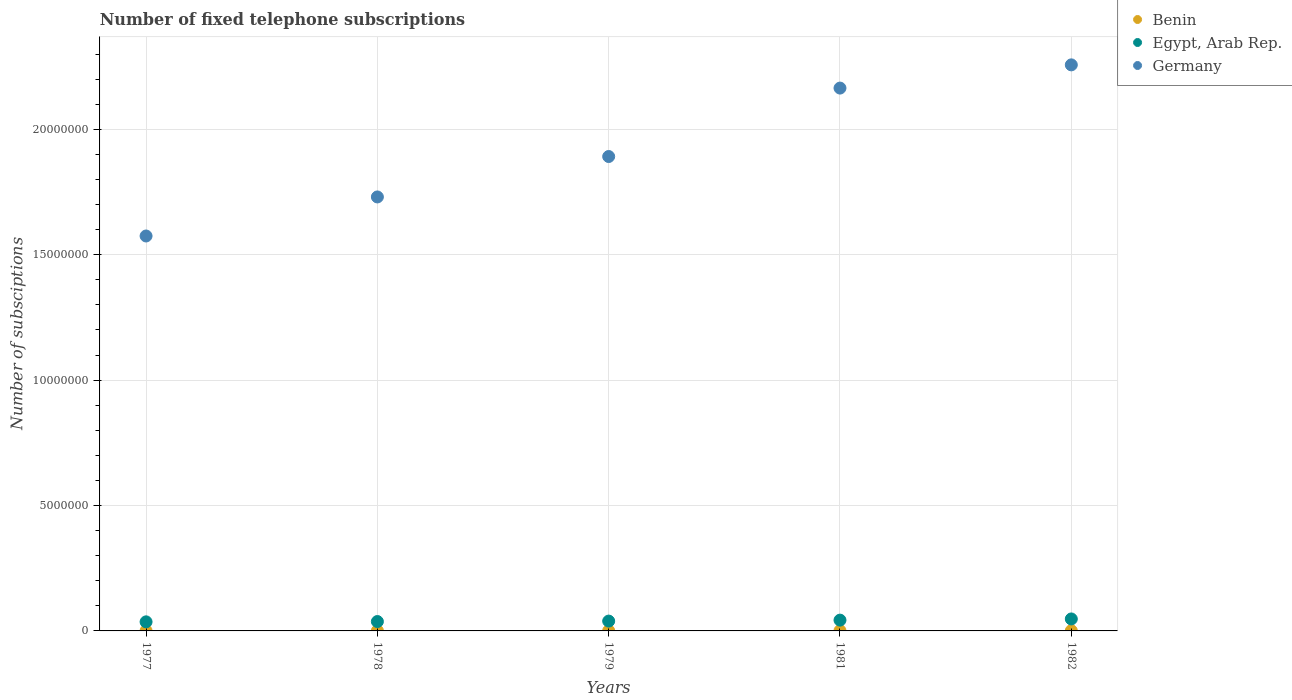Is the number of dotlines equal to the number of legend labels?
Make the answer very short. Yes. What is the number of fixed telephone subscriptions in Germany in 1978?
Provide a short and direct response. 1.73e+07. Across all years, what is the maximum number of fixed telephone subscriptions in Egypt, Arab Rep.?
Provide a short and direct response. 4.77e+05. Across all years, what is the minimum number of fixed telephone subscriptions in Benin?
Offer a very short reply. 6371. In which year was the number of fixed telephone subscriptions in Egypt, Arab Rep. minimum?
Ensure brevity in your answer.  1977. What is the total number of fixed telephone subscriptions in Germany in the graph?
Offer a terse response. 9.62e+07. What is the difference between the number of fixed telephone subscriptions in Egypt, Arab Rep. in 1977 and that in 1981?
Provide a succinct answer. -6.80e+04. What is the difference between the number of fixed telephone subscriptions in Egypt, Arab Rep. in 1978 and the number of fixed telephone subscriptions in Germany in 1977?
Keep it short and to the point. -1.54e+07. What is the average number of fixed telephone subscriptions in Benin per year?
Give a very brief answer. 8036.8. In the year 1982, what is the difference between the number of fixed telephone subscriptions in Germany and number of fixed telephone subscriptions in Benin?
Provide a succinct answer. 2.26e+07. In how many years, is the number of fixed telephone subscriptions in Germany greater than 3000000?
Make the answer very short. 5. What is the ratio of the number of fixed telephone subscriptions in Benin in 1977 to that in 1978?
Offer a terse response. 0.91. Is the number of fixed telephone subscriptions in Benin in 1977 less than that in 1981?
Your answer should be very brief. Yes. What is the difference between the highest and the second highest number of fixed telephone subscriptions in Egypt, Arab Rep.?
Your response must be concise. 4.74e+04. What is the difference between the highest and the lowest number of fixed telephone subscriptions in Benin?
Provide a short and direct response. 3309. Is the sum of the number of fixed telephone subscriptions in Benin in 1978 and 1981 greater than the maximum number of fixed telephone subscriptions in Germany across all years?
Provide a succinct answer. No. Is it the case that in every year, the sum of the number of fixed telephone subscriptions in Germany and number of fixed telephone subscriptions in Egypt, Arab Rep.  is greater than the number of fixed telephone subscriptions in Benin?
Keep it short and to the point. Yes. Does the number of fixed telephone subscriptions in Germany monotonically increase over the years?
Your response must be concise. Yes. Is the number of fixed telephone subscriptions in Benin strictly greater than the number of fixed telephone subscriptions in Germany over the years?
Ensure brevity in your answer.  No. Is the number of fixed telephone subscriptions in Benin strictly less than the number of fixed telephone subscriptions in Germany over the years?
Make the answer very short. Yes. What is the difference between two consecutive major ticks on the Y-axis?
Your answer should be compact. 5.00e+06. Does the graph contain any zero values?
Provide a short and direct response. No. Does the graph contain grids?
Offer a terse response. Yes. What is the title of the graph?
Make the answer very short. Number of fixed telephone subscriptions. What is the label or title of the X-axis?
Give a very brief answer. Years. What is the label or title of the Y-axis?
Ensure brevity in your answer.  Number of subsciptions. What is the Number of subsciptions of Benin in 1977?
Your response must be concise. 6371. What is the Number of subsciptions of Egypt, Arab Rep. in 1977?
Make the answer very short. 3.62e+05. What is the Number of subsciptions in Germany in 1977?
Your answer should be very brief. 1.57e+07. What is the Number of subsciptions of Benin in 1978?
Give a very brief answer. 7032. What is the Number of subsciptions of Egypt, Arab Rep. in 1978?
Ensure brevity in your answer.  3.74e+05. What is the Number of subsciptions in Germany in 1978?
Your response must be concise. 1.73e+07. What is the Number of subsciptions of Benin in 1979?
Ensure brevity in your answer.  7692. What is the Number of subsciptions of Egypt, Arab Rep. in 1979?
Ensure brevity in your answer.  3.92e+05. What is the Number of subsciptions in Germany in 1979?
Your answer should be very brief. 1.89e+07. What is the Number of subsciptions in Benin in 1981?
Make the answer very short. 9409. What is the Number of subsciptions in Egypt, Arab Rep. in 1981?
Provide a short and direct response. 4.30e+05. What is the Number of subsciptions in Germany in 1981?
Provide a succinct answer. 2.16e+07. What is the Number of subsciptions in Benin in 1982?
Provide a succinct answer. 9680. What is the Number of subsciptions of Egypt, Arab Rep. in 1982?
Offer a very short reply. 4.77e+05. What is the Number of subsciptions of Germany in 1982?
Your answer should be compact. 2.26e+07. Across all years, what is the maximum Number of subsciptions in Benin?
Keep it short and to the point. 9680. Across all years, what is the maximum Number of subsciptions in Egypt, Arab Rep.?
Offer a very short reply. 4.77e+05. Across all years, what is the maximum Number of subsciptions of Germany?
Ensure brevity in your answer.  2.26e+07. Across all years, what is the minimum Number of subsciptions in Benin?
Keep it short and to the point. 6371. Across all years, what is the minimum Number of subsciptions in Egypt, Arab Rep.?
Keep it short and to the point. 3.62e+05. Across all years, what is the minimum Number of subsciptions of Germany?
Your answer should be compact. 1.57e+07. What is the total Number of subsciptions of Benin in the graph?
Provide a short and direct response. 4.02e+04. What is the total Number of subsciptions in Egypt, Arab Rep. in the graph?
Offer a very short reply. 2.04e+06. What is the total Number of subsciptions in Germany in the graph?
Your answer should be very brief. 9.62e+07. What is the difference between the Number of subsciptions of Benin in 1977 and that in 1978?
Your answer should be compact. -661. What is the difference between the Number of subsciptions in Egypt, Arab Rep. in 1977 and that in 1978?
Your answer should be very brief. -1.20e+04. What is the difference between the Number of subsciptions of Germany in 1977 and that in 1978?
Provide a short and direct response. -1.56e+06. What is the difference between the Number of subsciptions of Benin in 1977 and that in 1979?
Make the answer very short. -1321. What is the difference between the Number of subsciptions in Germany in 1977 and that in 1979?
Ensure brevity in your answer.  -3.17e+06. What is the difference between the Number of subsciptions in Benin in 1977 and that in 1981?
Make the answer very short. -3038. What is the difference between the Number of subsciptions of Egypt, Arab Rep. in 1977 and that in 1981?
Keep it short and to the point. -6.80e+04. What is the difference between the Number of subsciptions of Germany in 1977 and that in 1981?
Offer a very short reply. -5.90e+06. What is the difference between the Number of subsciptions in Benin in 1977 and that in 1982?
Give a very brief answer. -3309. What is the difference between the Number of subsciptions of Egypt, Arab Rep. in 1977 and that in 1982?
Give a very brief answer. -1.15e+05. What is the difference between the Number of subsciptions of Germany in 1977 and that in 1982?
Provide a succinct answer. -6.82e+06. What is the difference between the Number of subsciptions of Benin in 1978 and that in 1979?
Make the answer very short. -660. What is the difference between the Number of subsciptions in Egypt, Arab Rep. in 1978 and that in 1979?
Make the answer very short. -1.80e+04. What is the difference between the Number of subsciptions in Germany in 1978 and that in 1979?
Keep it short and to the point. -1.61e+06. What is the difference between the Number of subsciptions in Benin in 1978 and that in 1981?
Give a very brief answer. -2377. What is the difference between the Number of subsciptions of Egypt, Arab Rep. in 1978 and that in 1981?
Provide a short and direct response. -5.60e+04. What is the difference between the Number of subsciptions of Germany in 1978 and that in 1981?
Offer a terse response. -4.34e+06. What is the difference between the Number of subsciptions in Benin in 1978 and that in 1982?
Provide a succinct answer. -2648. What is the difference between the Number of subsciptions in Egypt, Arab Rep. in 1978 and that in 1982?
Ensure brevity in your answer.  -1.03e+05. What is the difference between the Number of subsciptions in Germany in 1978 and that in 1982?
Offer a very short reply. -5.27e+06. What is the difference between the Number of subsciptions in Benin in 1979 and that in 1981?
Make the answer very short. -1717. What is the difference between the Number of subsciptions of Egypt, Arab Rep. in 1979 and that in 1981?
Give a very brief answer. -3.80e+04. What is the difference between the Number of subsciptions of Germany in 1979 and that in 1981?
Provide a short and direct response. -2.73e+06. What is the difference between the Number of subsciptions in Benin in 1979 and that in 1982?
Keep it short and to the point. -1988. What is the difference between the Number of subsciptions of Egypt, Arab Rep. in 1979 and that in 1982?
Provide a succinct answer. -8.54e+04. What is the difference between the Number of subsciptions of Germany in 1979 and that in 1982?
Your answer should be very brief. -3.65e+06. What is the difference between the Number of subsciptions of Benin in 1981 and that in 1982?
Keep it short and to the point. -271. What is the difference between the Number of subsciptions of Egypt, Arab Rep. in 1981 and that in 1982?
Your response must be concise. -4.74e+04. What is the difference between the Number of subsciptions in Germany in 1981 and that in 1982?
Your answer should be compact. -9.26e+05. What is the difference between the Number of subsciptions in Benin in 1977 and the Number of subsciptions in Egypt, Arab Rep. in 1978?
Your response must be concise. -3.68e+05. What is the difference between the Number of subsciptions in Benin in 1977 and the Number of subsciptions in Germany in 1978?
Keep it short and to the point. -1.73e+07. What is the difference between the Number of subsciptions in Egypt, Arab Rep. in 1977 and the Number of subsciptions in Germany in 1978?
Provide a short and direct response. -1.69e+07. What is the difference between the Number of subsciptions of Benin in 1977 and the Number of subsciptions of Egypt, Arab Rep. in 1979?
Provide a short and direct response. -3.86e+05. What is the difference between the Number of subsciptions in Benin in 1977 and the Number of subsciptions in Germany in 1979?
Your answer should be compact. -1.89e+07. What is the difference between the Number of subsciptions in Egypt, Arab Rep. in 1977 and the Number of subsciptions in Germany in 1979?
Offer a terse response. -1.86e+07. What is the difference between the Number of subsciptions of Benin in 1977 and the Number of subsciptions of Egypt, Arab Rep. in 1981?
Your response must be concise. -4.24e+05. What is the difference between the Number of subsciptions of Benin in 1977 and the Number of subsciptions of Germany in 1981?
Ensure brevity in your answer.  -2.16e+07. What is the difference between the Number of subsciptions in Egypt, Arab Rep. in 1977 and the Number of subsciptions in Germany in 1981?
Provide a short and direct response. -2.13e+07. What is the difference between the Number of subsciptions in Benin in 1977 and the Number of subsciptions in Egypt, Arab Rep. in 1982?
Give a very brief answer. -4.71e+05. What is the difference between the Number of subsciptions of Benin in 1977 and the Number of subsciptions of Germany in 1982?
Ensure brevity in your answer.  -2.26e+07. What is the difference between the Number of subsciptions of Egypt, Arab Rep. in 1977 and the Number of subsciptions of Germany in 1982?
Keep it short and to the point. -2.22e+07. What is the difference between the Number of subsciptions in Benin in 1978 and the Number of subsciptions in Egypt, Arab Rep. in 1979?
Give a very brief answer. -3.85e+05. What is the difference between the Number of subsciptions of Benin in 1978 and the Number of subsciptions of Germany in 1979?
Offer a very short reply. -1.89e+07. What is the difference between the Number of subsciptions of Egypt, Arab Rep. in 1978 and the Number of subsciptions of Germany in 1979?
Your answer should be compact. -1.85e+07. What is the difference between the Number of subsciptions in Benin in 1978 and the Number of subsciptions in Egypt, Arab Rep. in 1981?
Your response must be concise. -4.23e+05. What is the difference between the Number of subsciptions of Benin in 1978 and the Number of subsciptions of Germany in 1981?
Keep it short and to the point. -2.16e+07. What is the difference between the Number of subsciptions in Egypt, Arab Rep. in 1978 and the Number of subsciptions in Germany in 1981?
Your response must be concise. -2.13e+07. What is the difference between the Number of subsciptions in Benin in 1978 and the Number of subsciptions in Egypt, Arab Rep. in 1982?
Offer a very short reply. -4.70e+05. What is the difference between the Number of subsciptions of Benin in 1978 and the Number of subsciptions of Germany in 1982?
Offer a very short reply. -2.26e+07. What is the difference between the Number of subsciptions in Egypt, Arab Rep. in 1978 and the Number of subsciptions in Germany in 1982?
Ensure brevity in your answer.  -2.22e+07. What is the difference between the Number of subsciptions in Benin in 1979 and the Number of subsciptions in Egypt, Arab Rep. in 1981?
Offer a terse response. -4.22e+05. What is the difference between the Number of subsciptions of Benin in 1979 and the Number of subsciptions of Germany in 1981?
Ensure brevity in your answer.  -2.16e+07. What is the difference between the Number of subsciptions of Egypt, Arab Rep. in 1979 and the Number of subsciptions of Germany in 1981?
Provide a succinct answer. -2.13e+07. What is the difference between the Number of subsciptions of Benin in 1979 and the Number of subsciptions of Egypt, Arab Rep. in 1982?
Your response must be concise. -4.70e+05. What is the difference between the Number of subsciptions of Benin in 1979 and the Number of subsciptions of Germany in 1982?
Your answer should be very brief. -2.26e+07. What is the difference between the Number of subsciptions in Egypt, Arab Rep. in 1979 and the Number of subsciptions in Germany in 1982?
Your response must be concise. -2.22e+07. What is the difference between the Number of subsciptions in Benin in 1981 and the Number of subsciptions in Egypt, Arab Rep. in 1982?
Your response must be concise. -4.68e+05. What is the difference between the Number of subsciptions of Benin in 1981 and the Number of subsciptions of Germany in 1982?
Provide a short and direct response. -2.26e+07. What is the difference between the Number of subsciptions in Egypt, Arab Rep. in 1981 and the Number of subsciptions in Germany in 1982?
Give a very brief answer. -2.21e+07. What is the average Number of subsciptions of Benin per year?
Your answer should be compact. 8036.8. What is the average Number of subsciptions of Egypt, Arab Rep. per year?
Provide a short and direct response. 4.07e+05. What is the average Number of subsciptions of Germany per year?
Provide a succinct answer. 1.92e+07. In the year 1977, what is the difference between the Number of subsciptions in Benin and Number of subsciptions in Egypt, Arab Rep.?
Your answer should be very brief. -3.56e+05. In the year 1977, what is the difference between the Number of subsciptions in Benin and Number of subsciptions in Germany?
Provide a succinct answer. -1.57e+07. In the year 1977, what is the difference between the Number of subsciptions in Egypt, Arab Rep. and Number of subsciptions in Germany?
Offer a terse response. -1.54e+07. In the year 1978, what is the difference between the Number of subsciptions in Benin and Number of subsciptions in Egypt, Arab Rep.?
Make the answer very short. -3.67e+05. In the year 1978, what is the difference between the Number of subsciptions in Benin and Number of subsciptions in Germany?
Provide a succinct answer. -1.73e+07. In the year 1978, what is the difference between the Number of subsciptions of Egypt, Arab Rep. and Number of subsciptions of Germany?
Your response must be concise. -1.69e+07. In the year 1979, what is the difference between the Number of subsciptions in Benin and Number of subsciptions in Egypt, Arab Rep.?
Offer a very short reply. -3.84e+05. In the year 1979, what is the difference between the Number of subsciptions in Benin and Number of subsciptions in Germany?
Keep it short and to the point. -1.89e+07. In the year 1979, what is the difference between the Number of subsciptions in Egypt, Arab Rep. and Number of subsciptions in Germany?
Your answer should be very brief. -1.85e+07. In the year 1981, what is the difference between the Number of subsciptions in Benin and Number of subsciptions in Egypt, Arab Rep.?
Your answer should be very brief. -4.21e+05. In the year 1981, what is the difference between the Number of subsciptions of Benin and Number of subsciptions of Germany?
Give a very brief answer. -2.16e+07. In the year 1981, what is the difference between the Number of subsciptions in Egypt, Arab Rep. and Number of subsciptions in Germany?
Your answer should be compact. -2.12e+07. In the year 1982, what is the difference between the Number of subsciptions of Benin and Number of subsciptions of Egypt, Arab Rep.?
Give a very brief answer. -4.68e+05. In the year 1982, what is the difference between the Number of subsciptions of Benin and Number of subsciptions of Germany?
Your answer should be compact. -2.26e+07. In the year 1982, what is the difference between the Number of subsciptions in Egypt, Arab Rep. and Number of subsciptions in Germany?
Provide a short and direct response. -2.21e+07. What is the ratio of the Number of subsciptions in Benin in 1977 to that in 1978?
Ensure brevity in your answer.  0.91. What is the ratio of the Number of subsciptions of Egypt, Arab Rep. in 1977 to that in 1978?
Give a very brief answer. 0.97. What is the ratio of the Number of subsciptions in Germany in 1977 to that in 1978?
Offer a terse response. 0.91. What is the ratio of the Number of subsciptions of Benin in 1977 to that in 1979?
Give a very brief answer. 0.83. What is the ratio of the Number of subsciptions in Egypt, Arab Rep. in 1977 to that in 1979?
Keep it short and to the point. 0.92. What is the ratio of the Number of subsciptions of Germany in 1977 to that in 1979?
Provide a short and direct response. 0.83. What is the ratio of the Number of subsciptions of Benin in 1977 to that in 1981?
Your answer should be compact. 0.68. What is the ratio of the Number of subsciptions in Egypt, Arab Rep. in 1977 to that in 1981?
Provide a succinct answer. 0.84. What is the ratio of the Number of subsciptions of Germany in 1977 to that in 1981?
Make the answer very short. 0.73. What is the ratio of the Number of subsciptions of Benin in 1977 to that in 1982?
Offer a very short reply. 0.66. What is the ratio of the Number of subsciptions of Egypt, Arab Rep. in 1977 to that in 1982?
Ensure brevity in your answer.  0.76. What is the ratio of the Number of subsciptions of Germany in 1977 to that in 1982?
Make the answer very short. 0.7. What is the ratio of the Number of subsciptions of Benin in 1978 to that in 1979?
Offer a terse response. 0.91. What is the ratio of the Number of subsciptions of Egypt, Arab Rep. in 1978 to that in 1979?
Give a very brief answer. 0.95. What is the ratio of the Number of subsciptions in Germany in 1978 to that in 1979?
Make the answer very short. 0.91. What is the ratio of the Number of subsciptions in Benin in 1978 to that in 1981?
Provide a succinct answer. 0.75. What is the ratio of the Number of subsciptions of Egypt, Arab Rep. in 1978 to that in 1981?
Your answer should be compact. 0.87. What is the ratio of the Number of subsciptions of Germany in 1978 to that in 1981?
Offer a very short reply. 0.8. What is the ratio of the Number of subsciptions in Benin in 1978 to that in 1982?
Your answer should be compact. 0.73. What is the ratio of the Number of subsciptions in Egypt, Arab Rep. in 1978 to that in 1982?
Your answer should be compact. 0.78. What is the ratio of the Number of subsciptions in Germany in 1978 to that in 1982?
Make the answer very short. 0.77. What is the ratio of the Number of subsciptions in Benin in 1979 to that in 1981?
Give a very brief answer. 0.82. What is the ratio of the Number of subsciptions of Egypt, Arab Rep. in 1979 to that in 1981?
Offer a very short reply. 0.91. What is the ratio of the Number of subsciptions in Germany in 1979 to that in 1981?
Provide a succinct answer. 0.87. What is the ratio of the Number of subsciptions of Benin in 1979 to that in 1982?
Your response must be concise. 0.79. What is the ratio of the Number of subsciptions in Egypt, Arab Rep. in 1979 to that in 1982?
Keep it short and to the point. 0.82. What is the ratio of the Number of subsciptions of Germany in 1979 to that in 1982?
Ensure brevity in your answer.  0.84. What is the ratio of the Number of subsciptions in Egypt, Arab Rep. in 1981 to that in 1982?
Offer a very short reply. 0.9. What is the difference between the highest and the second highest Number of subsciptions of Benin?
Your answer should be very brief. 271. What is the difference between the highest and the second highest Number of subsciptions of Egypt, Arab Rep.?
Your answer should be compact. 4.74e+04. What is the difference between the highest and the second highest Number of subsciptions of Germany?
Provide a succinct answer. 9.26e+05. What is the difference between the highest and the lowest Number of subsciptions in Benin?
Make the answer very short. 3309. What is the difference between the highest and the lowest Number of subsciptions of Egypt, Arab Rep.?
Give a very brief answer. 1.15e+05. What is the difference between the highest and the lowest Number of subsciptions in Germany?
Offer a very short reply. 6.82e+06. 